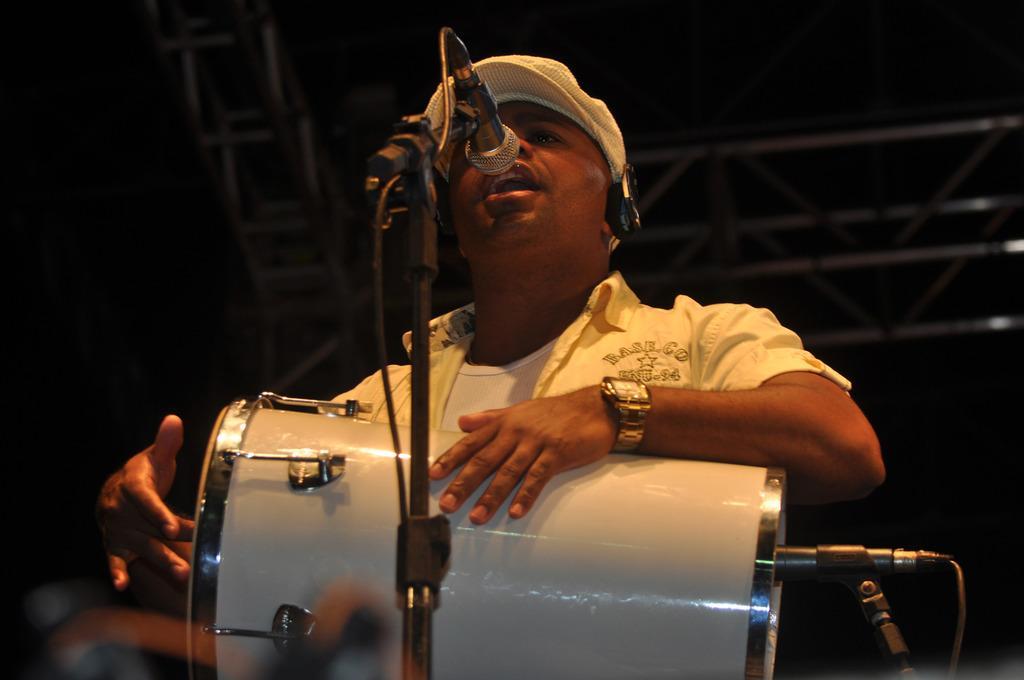How would you summarize this image in a sentence or two? He is standing. He is wearing a watch. He is singing a song. He is holding a musical drum. He is wearing a headphone and cap. He is singing a song. We can see in background black color curtain. 